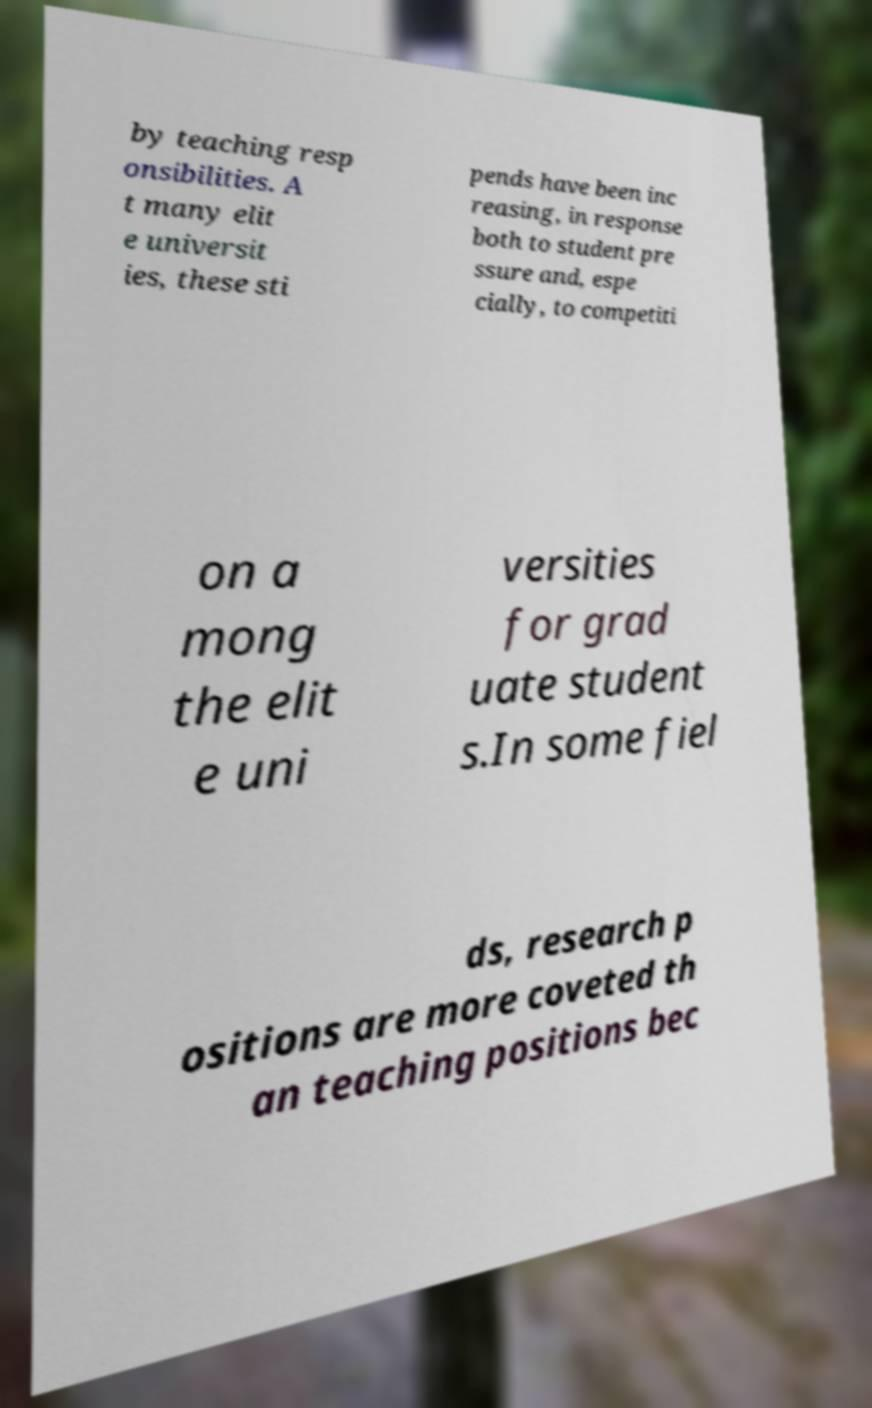Please identify and transcribe the text found in this image. by teaching resp onsibilities. A t many elit e universit ies, these sti pends have been inc reasing, in response both to student pre ssure and, espe cially, to competiti on a mong the elit e uni versities for grad uate student s.In some fiel ds, research p ositions are more coveted th an teaching positions bec 